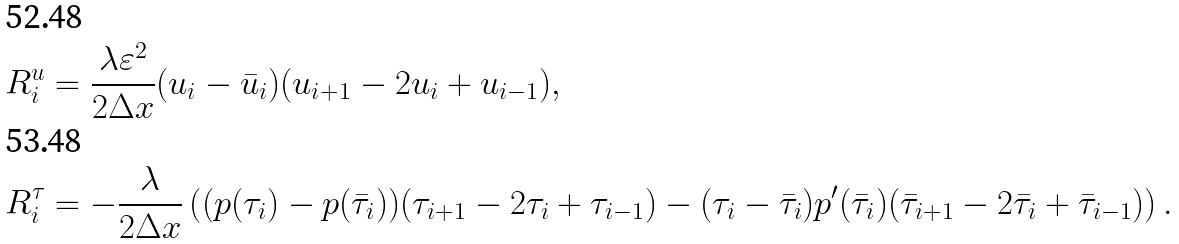<formula> <loc_0><loc_0><loc_500><loc_500>R _ { i } ^ { u } & = \frac { \lambda \varepsilon ^ { 2 } } { 2 \Delta x } ( u _ { i } - \bar { u } _ { i } ) ( u _ { i + 1 } - 2 u _ { i } + u _ { i - 1 } ) , \\ R _ { i } ^ { \tau } & = - \frac { \lambda } { 2 \Delta x } \left ( ( p ( \tau _ { i } ) - p ( \bar { \tau } _ { i } ) ) ( \tau _ { i + 1 } - 2 \tau _ { i } + \tau _ { i - 1 } ) - ( \tau _ { i } - \bar { \tau } _ { i } ) p ^ { \prime } ( \bar { \tau } _ { i } ) ( \bar { \tau } _ { i + 1 } - 2 \bar { \tau } _ { i } + \bar { \tau } _ { i - 1 } ) \right ) .</formula> 